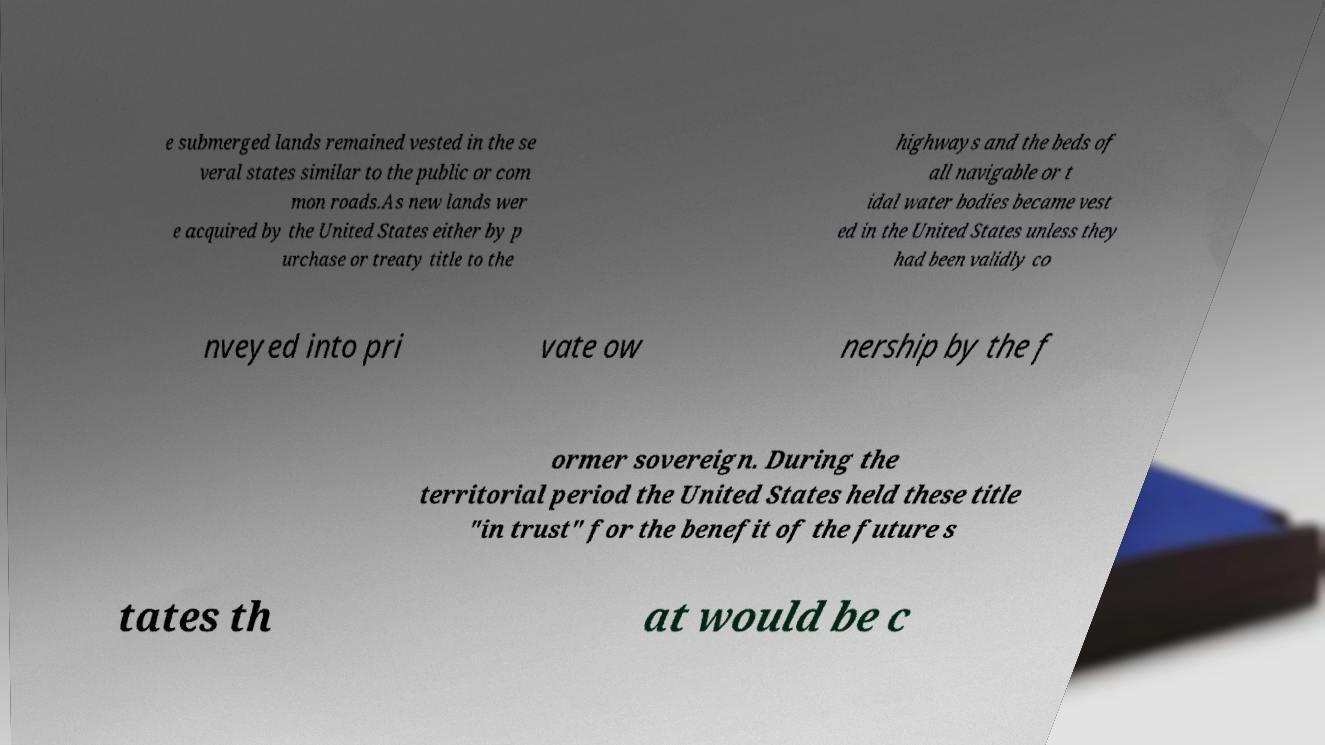Can you read and provide the text displayed in the image?This photo seems to have some interesting text. Can you extract and type it out for me? e submerged lands remained vested in the se veral states similar to the public or com mon roads.As new lands wer e acquired by the United States either by p urchase or treaty title to the highways and the beds of all navigable or t idal water bodies became vest ed in the United States unless they had been validly co nveyed into pri vate ow nership by the f ormer sovereign. During the territorial period the United States held these title "in trust" for the benefit of the future s tates th at would be c 